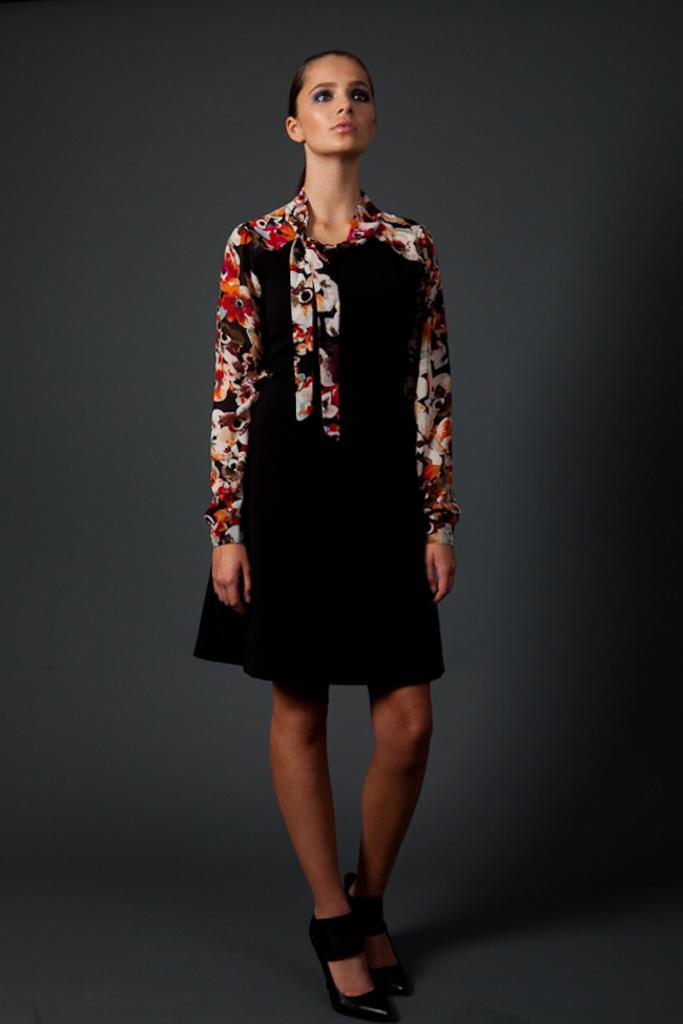Please provide a concise description of this image. In the center of this picture we can see a person wearing black color dress with floral sleeves and standing. 